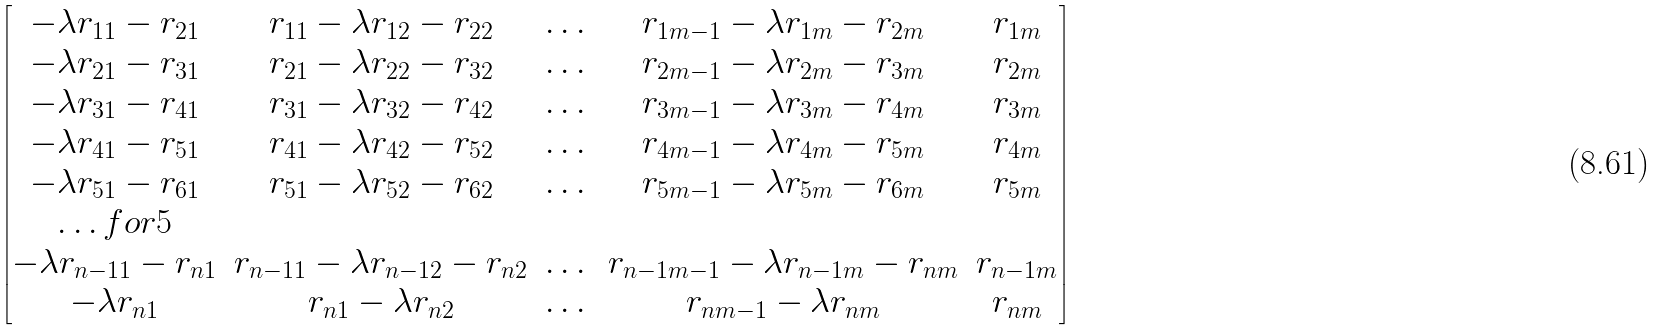Convert formula to latex. <formula><loc_0><loc_0><loc_500><loc_500>\begin{bmatrix} - \lambda r _ { 1 1 } - r _ { 2 1 } & r _ { 1 1 } - \lambda r _ { 1 2 } - r _ { 2 2 } & \dots & r _ { 1 m - 1 } - \lambda r _ { 1 m } - r _ { 2 m } & r _ { 1 m } \\ - \lambda r _ { 2 1 } - r _ { 3 1 } & r _ { 2 1 } - \lambda r _ { 2 2 } - r _ { 3 2 } & \dots & r _ { 2 m - 1 } - \lambda r _ { 2 m } - r _ { 3 m } & r _ { 2 m } \\ - \lambda r _ { 3 1 } - r _ { 4 1 } & r _ { 3 1 } - \lambda r _ { 3 2 } - r _ { 4 2 } & \dots & r _ { 3 m - 1 } - \lambda r _ { 3 m } - r _ { 4 m } & r _ { 3 m } \\ - \lambda r _ { 4 1 } - r _ { 5 1 } & r _ { 4 1 } - \lambda r _ { 4 2 } - r _ { 5 2 } & \dots & r _ { 4 m - 1 } - \lambda r _ { 4 m } - r _ { 5 m } & r _ { 4 m } \\ - \lambda r _ { 5 1 } - r _ { 6 1 } & r _ { 5 1 } - \lambda r _ { 5 2 } - r _ { 6 2 } & \dots & r _ { 5 m - 1 } - \lambda r _ { 5 m } - r _ { 6 m } & r _ { 5 m } \\ \hdots f o r { 5 } \\ - \lambda r _ { n - 1 1 } - r _ { n 1 } & r _ { n - 1 1 } - \lambda r _ { n - 1 2 } - r _ { n 2 } & \dots & r _ { n - 1 m - 1 } - \lambda r _ { n - 1 m } - r _ { n m } & r _ { n - 1 m } \\ - \lambda r _ { n 1 } & r _ { n 1 } - \lambda r _ { n 2 } & \dots & r _ { n m - 1 } - \lambda r _ { n m } & r _ { n m } \\ \end{bmatrix}</formula> 